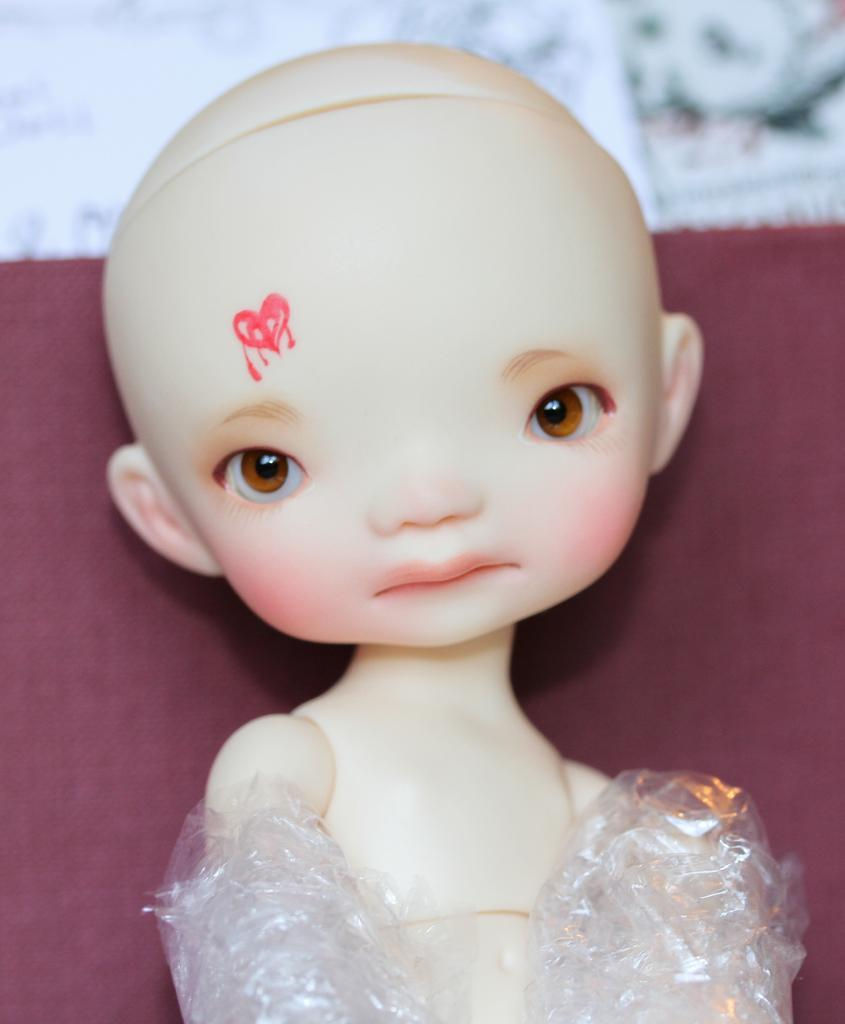What is the main subject in the middle of the image? There is a doll in the middle of the image. What color is the background of the image? The background color is maroon. Where is the cub located in the image? There is no cub present in the image. What type of furniture can be seen in the image? The image does not show any furniture, such as a bed. Can you see any boats or ships in the image? The image does not depict a harbor or any boats or ships. 